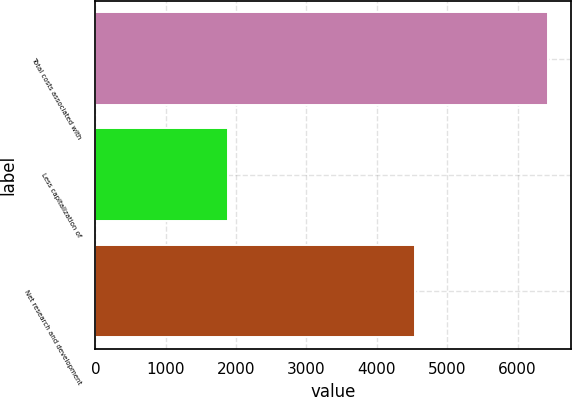Convert chart. <chart><loc_0><loc_0><loc_500><loc_500><bar_chart><fcel>Total costs associated with<fcel>Less capitalization of<fcel>Net research and development<nl><fcel>6437<fcel>1891<fcel>4546<nl></chart> 